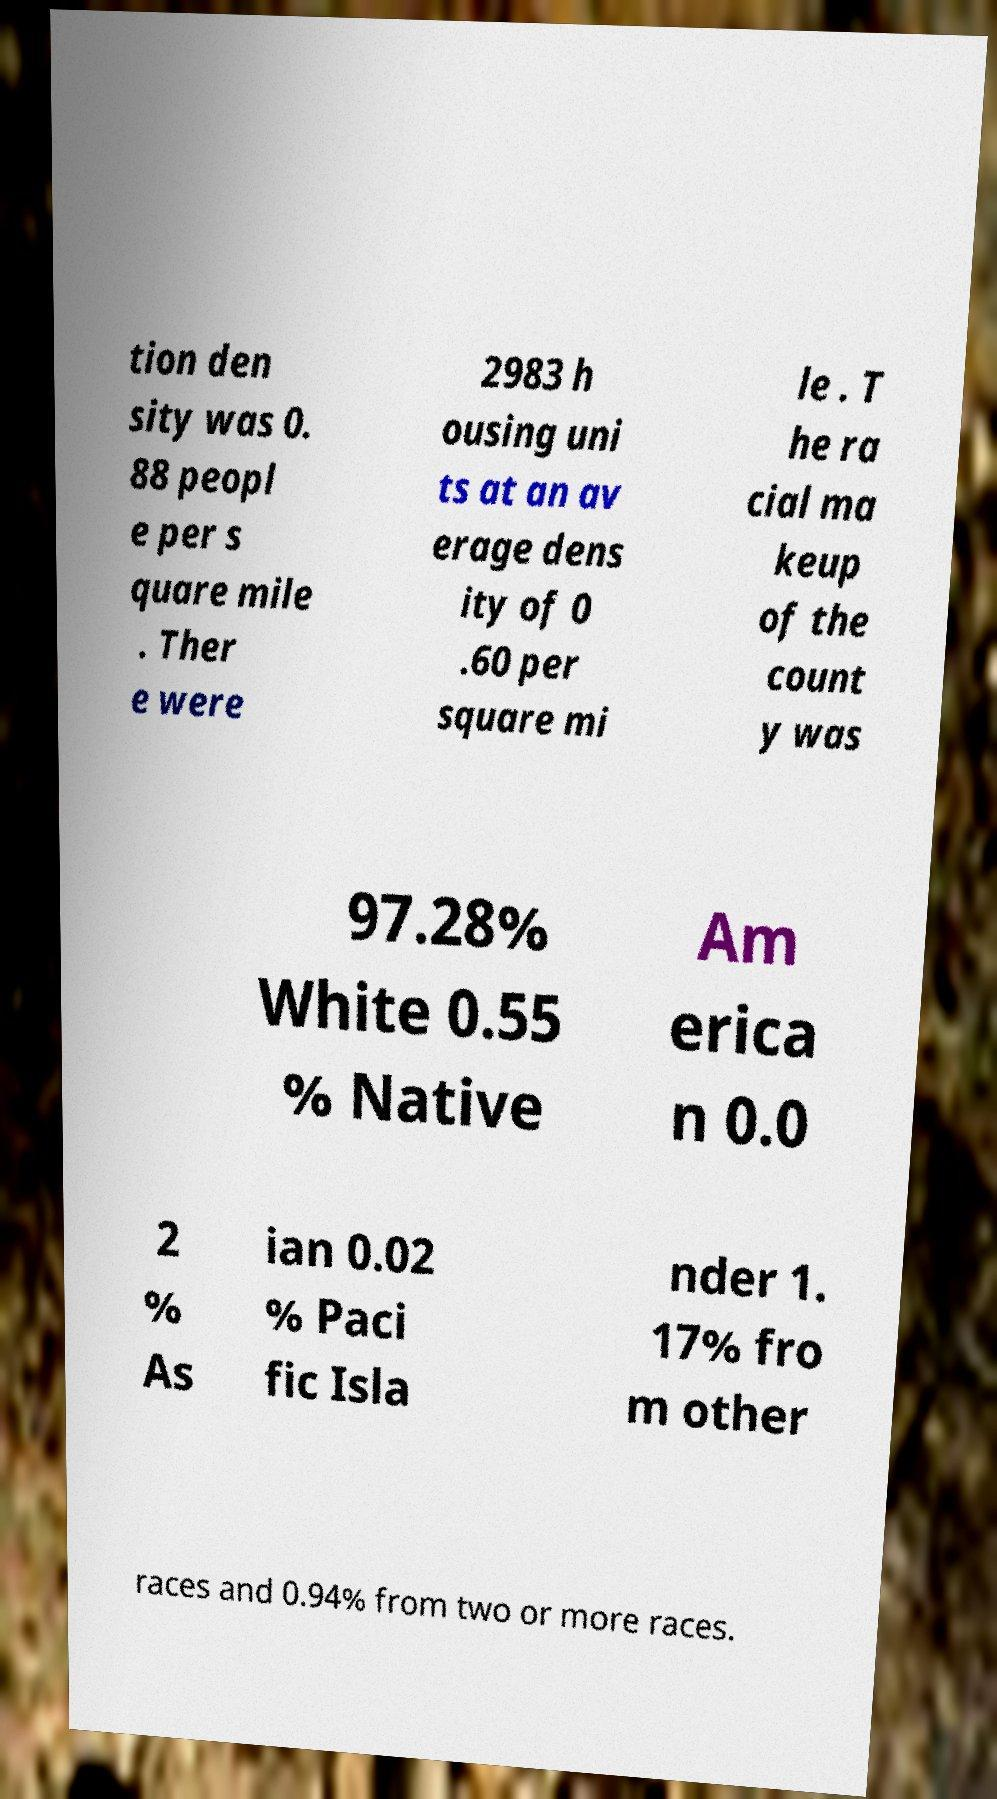Can you read and provide the text displayed in the image?This photo seems to have some interesting text. Can you extract and type it out for me? tion den sity was 0. 88 peopl e per s quare mile . Ther e were 2983 h ousing uni ts at an av erage dens ity of 0 .60 per square mi le . T he ra cial ma keup of the count y was 97.28% White 0.55 % Native Am erica n 0.0 2 % As ian 0.02 % Paci fic Isla nder 1. 17% fro m other races and 0.94% from two or more races. 